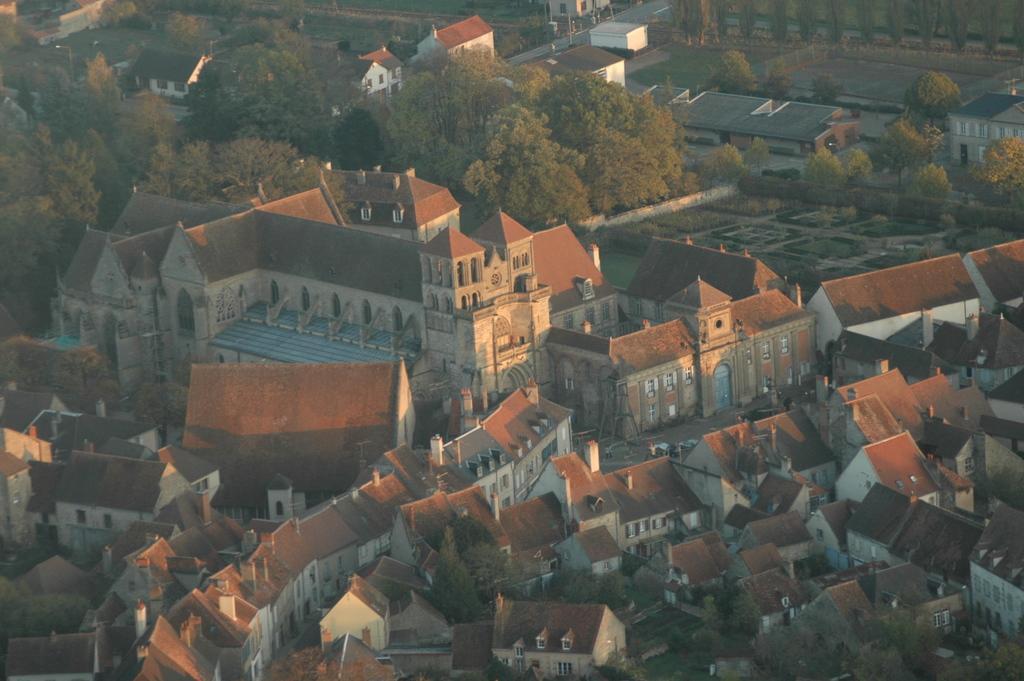In one or two sentences, can you explain what this image depicts? In this picture I can observe buildings in the middle of the picture. There are some trees in between the buildings in this picture. 